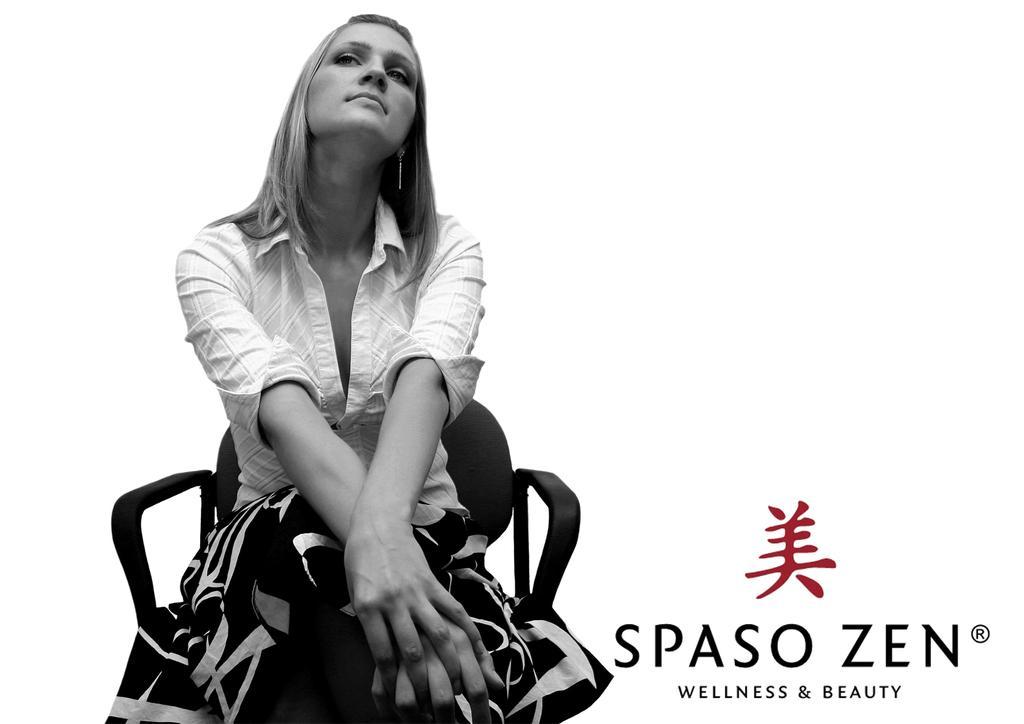Describe this image in one or two sentences. This is a black and white pic. We can see a woman is sitting on a chair on the left side and on the right side there is a logo and text written on the image. In the background the image is white in color. 